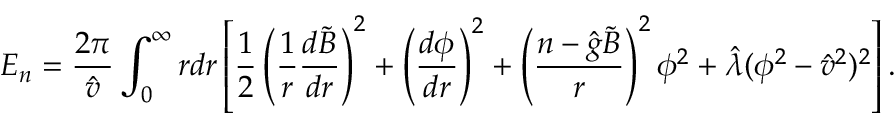<formula> <loc_0><loc_0><loc_500><loc_500>E _ { n } = \frac { 2 \pi } { \hat { v } } \int _ { 0 } ^ { \infty } r d r \left [ \frac { 1 } { 2 } \left ( \frac { 1 } { r } \frac { d \tilde { B } } { d r } \right ) ^ { 2 } + \left ( \frac { d \phi } { d r } \right ) ^ { 2 } + \left ( \frac { n - \hat { g } \tilde { B } } { r } \right ) ^ { 2 } \phi ^ { 2 } + \hat { \lambda } ( \phi ^ { 2 } - \hat { v } ^ { 2 } ) ^ { 2 } \right ] .</formula> 